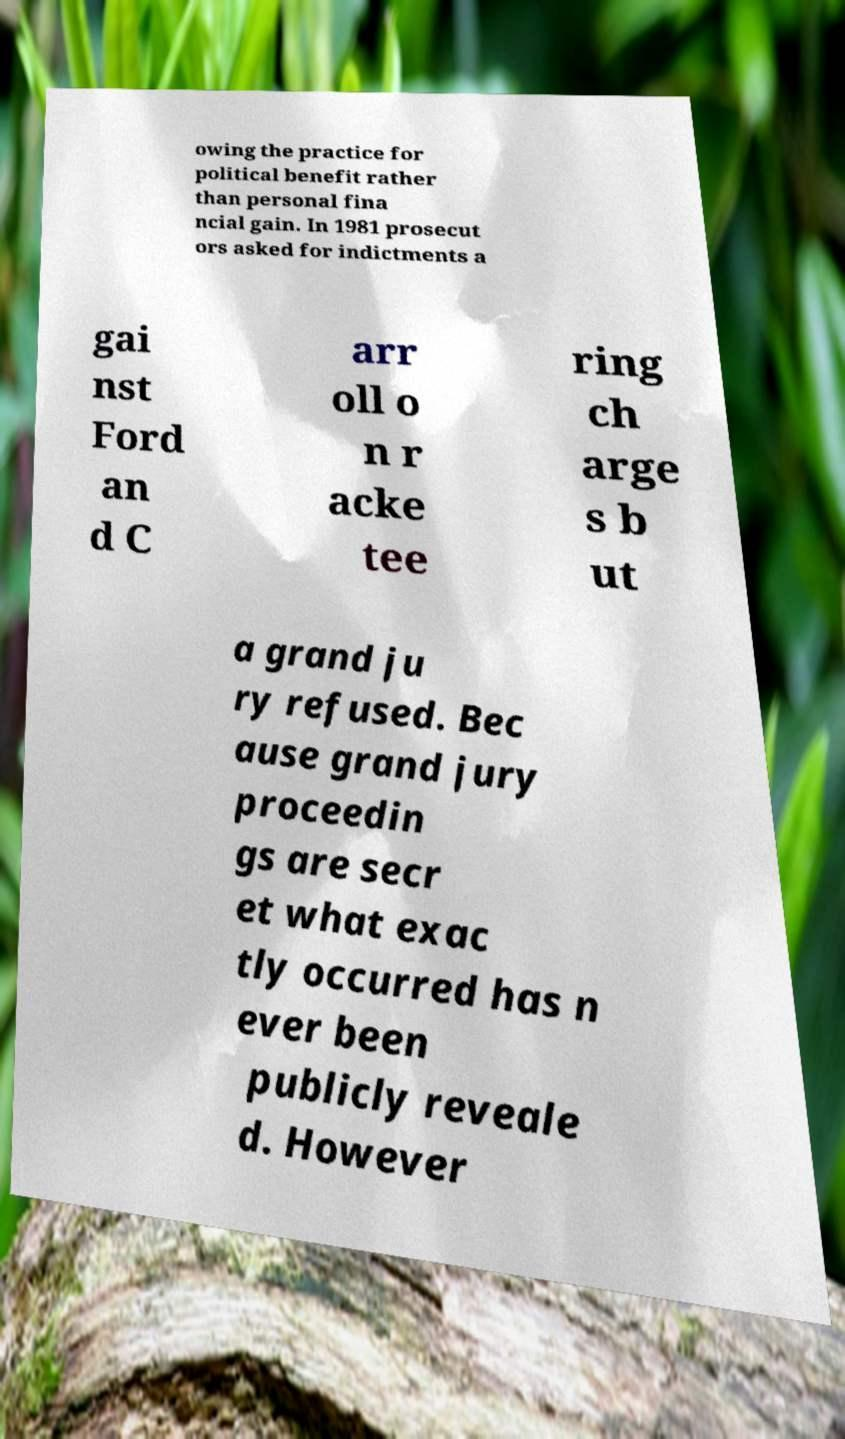For documentation purposes, I need the text within this image transcribed. Could you provide that? owing the practice for political benefit rather than personal fina ncial gain. In 1981 prosecut ors asked for indictments a gai nst Ford an d C arr oll o n r acke tee ring ch arge s b ut a grand ju ry refused. Bec ause grand jury proceedin gs are secr et what exac tly occurred has n ever been publicly reveale d. However 